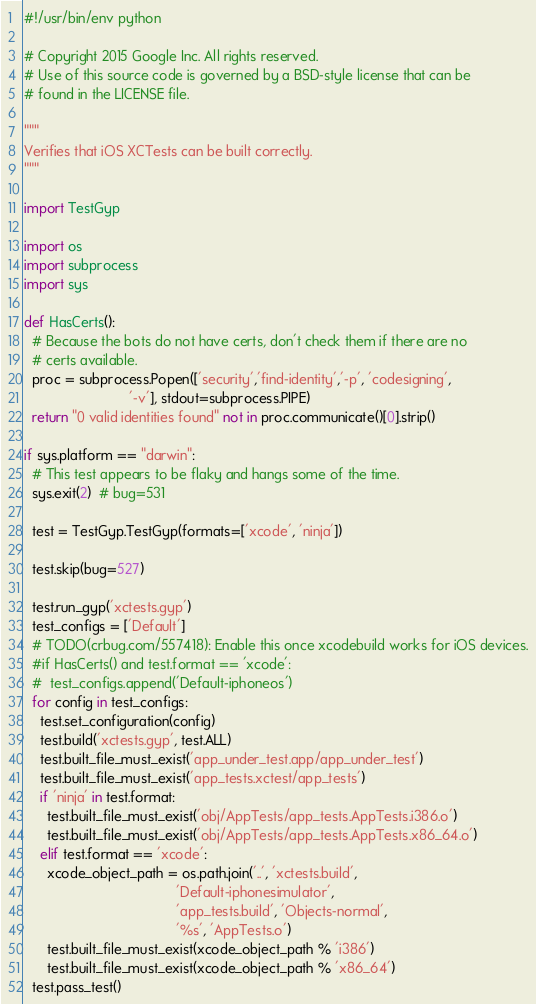<code> <loc_0><loc_0><loc_500><loc_500><_Python_>#!/usr/bin/env python

# Copyright 2015 Google Inc. All rights reserved.
# Use of this source code is governed by a BSD-style license that can be
# found in the LICENSE file.

"""
Verifies that iOS XCTests can be built correctly.
"""

import TestGyp

import os
import subprocess
import sys

def HasCerts():
  # Because the bots do not have certs, don't check them if there are no
  # certs available.
  proc = subprocess.Popen(['security','find-identity','-p', 'codesigning',
                           '-v'], stdout=subprocess.PIPE)
  return "0 valid identities found" not in proc.communicate()[0].strip()

if sys.platform == "darwin":
  # This test appears to be flaky and hangs some of the time.
  sys.exit(2)  # bug=531

  test = TestGyp.TestGyp(formats=['xcode', 'ninja'])

  test.skip(bug=527)

  test.run_gyp('xctests.gyp')
  test_configs = ['Default']
  # TODO(crbug.com/557418): Enable this once xcodebuild works for iOS devices.
  #if HasCerts() and test.format == 'xcode':
  #  test_configs.append('Default-iphoneos')
  for config in test_configs:
    test.set_configuration(config)
    test.build('xctests.gyp', test.ALL)
    test.built_file_must_exist('app_under_test.app/app_under_test')
    test.built_file_must_exist('app_tests.xctest/app_tests')
    if 'ninja' in test.format:
      test.built_file_must_exist('obj/AppTests/app_tests.AppTests.i386.o')
      test.built_file_must_exist('obj/AppTests/app_tests.AppTests.x86_64.o')
    elif test.format == 'xcode':
      xcode_object_path = os.path.join('..', 'xctests.build',
                                       'Default-iphonesimulator',
                                       'app_tests.build', 'Objects-normal',
                                       '%s', 'AppTests.o')
      test.built_file_must_exist(xcode_object_path % 'i386')
      test.built_file_must_exist(xcode_object_path % 'x86_64')
  test.pass_test()
</code> 